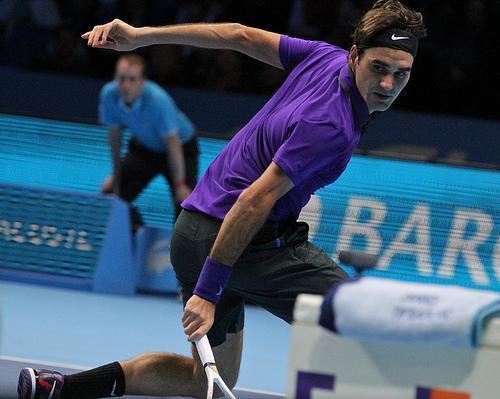How many people are in the photo?
Give a very brief answer. 2. 